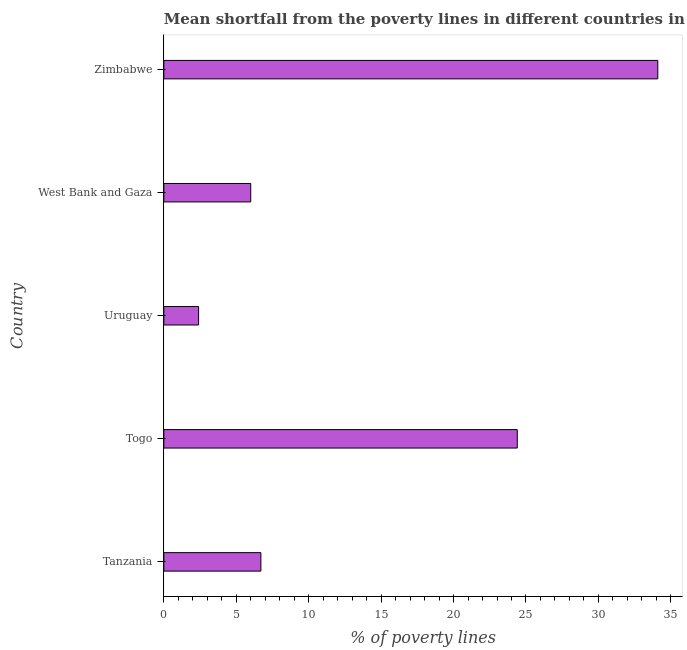Does the graph contain grids?
Offer a terse response. No. What is the title of the graph?
Make the answer very short. Mean shortfall from the poverty lines in different countries in 2011. What is the label or title of the X-axis?
Provide a short and direct response. % of poverty lines. Across all countries, what is the maximum poverty gap at national poverty lines?
Your answer should be compact. 34.1. In which country was the poverty gap at national poverty lines maximum?
Give a very brief answer. Zimbabwe. In which country was the poverty gap at national poverty lines minimum?
Your response must be concise. Uruguay. What is the sum of the poverty gap at national poverty lines?
Offer a terse response. 73.6. What is the average poverty gap at national poverty lines per country?
Give a very brief answer. 14.72. What is the ratio of the poverty gap at national poverty lines in Togo to that in Uruguay?
Provide a short and direct response. 10.17. What is the difference between the highest and the lowest poverty gap at national poverty lines?
Give a very brief answer. 31.7. Are all the bars in the graph horizontal?
Your answer should be very brief. Yes. Are the values on the major ticks of X-axis written in scientific E-notation?
Your response must be concise. No. What is the % of poverty lines of Togo?
Ensure brevity in your answer.  24.4. What is the % of poverty lines of Uruguay?
Offer a terse response. 2.4. What is the % of poverty lines of Zimbabwe?
Provide a succinct answer. 34.1. What is the difference between the % of poverty lines in Tanzania and Togo?
Your response must be concise. -17.7. What is the difference between the % of poverty lines in Tanzania and Uruguay?
Keep it short and to the point. 4.3. What is the difference between the % of poverty lines in Tanzania and West Bank and Gaza?
Make the answer very short. 0.7. What is the difference between the % of poverty lines in Tanzania and Zimbabwe?
Make the answer very short. -27.4. What is the difference between the % of poverty lines in Uruguay and Zimbabwe?
Provide a succinct answer. -31.7. What is the difference between the % of poverty lines in West Bank and Gaza and Zimbabwe?
Your answer should be very brief. -28.1. What is the ratio of the % of poverty lines in Tanzania to that in Togo?
Provide a succinct answer. 0.28. What is the ratio of the % of poverty lines in Tanzania to that in Uruguay?
Offer a very short reply. 2.79. What is the ratio of the % of poverty lines in Tanzania to that in West Bank and Gaza?
Give a very brief answer. 1.12. What is the ratio of the % of poverty lines in Tanzania to that in Zimbabwe?
Provide a succinct answer. 0.2. What is the ratio of the % of poverty lines in Togo to that in Uruguay?
Your answer should be very brief. 10.17. What is the ratio of the % of poverty lines in Togo to that in West Bank and Gaza?
Give a very brief answer. 4.07. What is the ratio of the % of poverty lines in Togo to that in Zimbabwe?
Give a very brief answer. 0.72. What is the ratio of the % of poverty lines in Uruguay to that in Zimbabwe?
Offer a terse response. 0.07. What is the ratio of the % of poverty lines in West Bank and Gaza to that in Zimbabwe?
Offer a terse response. 0.18. 